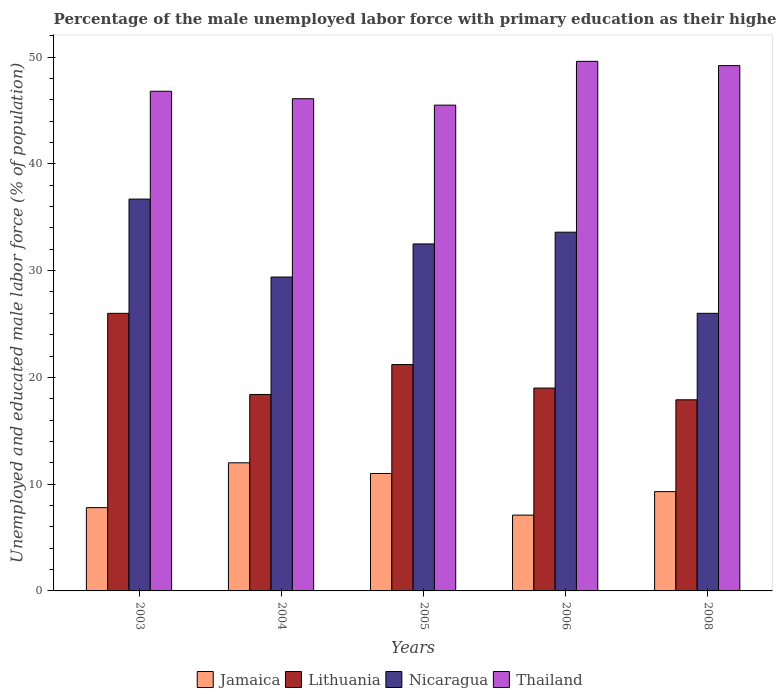How many groups of bars are there?
Provide a short and direct response. 5. How many bars are there on the 5th tick from the left?
Ensure brevity in your answer.  4. How many bars are there on the 4th tick from the right?
Provide a succinct answer. 4. What is the label of the 1st group of bars from the left?
Make the answer very short. 2003. What is the percentage of the unemployed male labor force with primary education in Jamaica in 2004?
Offer a terse response. 12. Across all years, what is the maximum percentage of the unemployed male labor force with primary education in Nicaragua?
Offer a terse response. 36.7. Across all years, what is the minimum percentage of the unemployed male labor force with primary education in Thailand?
Keep it short and to the point. 45.5. In which year was the percentage of the unemployed male labor force with primary education in Lithuania maximum?
Your answer should be compact. 2003. In which year was the percentage of the unemployed male labor force with primary education in Lithuania minimum?
Make the answer very short. 2008. What is the total percentage of the unemployed male labor force with primary education in Lithuania in the graph?
Give a very brief answer. 102.5. What is the difference between the percentage of the unemployed male labor force with primary education in Thailand in 2003 and that in 2004?
Ensure brevity in your answer.  0.7. What is the difference between the percentage of the unemployed male labor force with primary education in Nicaragua in 2005 and the percentage of the unemployed male labor force with primary education in Thailand in 2006?
Give a very brief answer. -17.1. What is the average percentage of the unemployed male labor force with primary education in Jamaica per year?
Give a very brief answer. 9.44. In the year 2004, what is the difference between the percentage of the unemployed male labor force with primary education in Thailand and percentage of the unemployed male labor force with primary education in Lithuania?
Ensure brevity in your answer.  27.7. What is the ratio of the percentage of the unemployed male labor force with primary education in Thailand in 2004 to that in 2006?
Offer a terse response. 0.93. Is the percentage of the unemployed male labor force with primary education in Thailand in 2004 less than that in 2006?
Make the answer very short. Yes. Is the difference between the percentage of the unemployed male labor force with primary education in Thailand in 2003 and 2006 greater than the difference between the percentage of the unemployed male labor force with primary education in Lithuania in 2003 and 2006?
Keep it short and to the point. No. What is the difference between the highest and the lowest percentage of the unemployed male labor force with primary education in Jamaica?
Keep it short and to the point. 4.9. Is it the case that in every year, the sum of the percentage of the unemployed male labor force with primary education in Lithuania and percentage of the unemployed male labor force with primary education in Jamaica is greater than the sum of percentage of the unemployed male labor force with primary education in Thailand and percentage of the unemployed male labor force with primary education in Nicaragua?
Your answer should be very brief. No. What does the 2nd bar from the left in 2004 represents?
Provide a short and direct response. Lithuania. What does the 2nd bar from the right in 2008 represents?
Give a very brief answer. Nicaragua. Is it the case that in every year, the sum of the percentage of the unemployed male labor force with primary education in Thailand and percentage of the unemployed male labor force with primary education in Lithuania is greater than the percentage of the unemployed male labor force with primary education in Nicaragua?
Make the answer very short. Yes. Are all the bars in the graph horizontal?
Give a very brief answer. No. Are the values on the major ticks of Y-axis written in scientific E-notation?
Your response must be concise. No. What is the title of the graph?
Ensure brevity in your answer.  Percentage of the male unemployed labor force with primary education as their highest grade. Does "Cayman Islands" appear as one of the legend labels in the graph?
Keep it short and to the point. No. What is the label or title of the X-axis?
Your answer should be compact. Years. What is the label or title of the Y-axis?
Offer a terse response. Unemployed and educated male labor force (% of population). What is the Unemployed and educated male labor force (% of population) in Jamaica in 2003?
Provide a succinct answer. 7.8. What is the Unemployed and educated male labor force (% of population) of Nicaragua in 2003?
Offer a very short reply. 36.7. What is the Unemployed and educated male labor force (% of population) in Thailand in 2003?
Your answer should be very brief. 46.8. What is the Unemployed and educated male labor force (% of population) in Lithuania in 2004?
Make the answer very short. 18.4. What is the Unemployed and educated male labor force (% of population) in Nicaragua in 2004?
Offer a very short reply. 29.4. What is the Unemployed and educated male labor force (% of population) in Thailand in 2004?
Your answer should be compact. 46.1. What is the Unemployed and educated male labor force (% of population) in Lithuania in 2005?
Provide a short and direct response. 21.2. What is the Unemployed and educated male labor force (% of population) in Nicaragua in 2005?
Make the answer very short. 32.5. What is the Unemployed and educated male labor force (% of population) of Thailand in 2005?
Make the answer very short. 45.5. What is the Unemployed and educated male labor force (% of population) in Jamaica in 2006?
Ensure brevity in your answer.  7.1. What is the Unemployed and educated male labor force (% of population) of Lithuania in 2006?
Give a very brief answer. 19. What is the Unemployed and educated male labor force (% of population) in Nicaragua in 2006?
Give a very brief answer. 33.6. What is the Unemployed and educated male labor force (% of population) of Thailand in 2006?
Provide a succinct answer. 49.6. What is the Unemployed and educated male labor force (% of population) in Jamaica in 2008?
Your response must be concise. 9.3. What is the Unemployed and educated male labor force (% of population) in Lithuania in 2008?
Offer a very short reply. 17.9. What is the Unemployed and educated male labor force (% of population) in Nicaragua in 2008?
Offer a terse response. 26. What is the Unemployed and educated male labor force (% of population) in Thailand in 2008?
Keep it short and to the point. 49.2. Across all years, what is the maximum Unemployed and educated male labor force (% of population) of Jamaica?
Ensure brevity in your answer.  12. Across all years, what is the maximum Unemployed and educated male labor force (% of population) of Lithuania?
Make the answer very short. 26. Across all years, what is the maximum Unemployed and educated male labor force (% of population) in Nicaragua?
Keep it short and to the point. 36.7. Across all years, what is the maximum Unemployed and educated male labor force (% of population) in Thailand?
Make the answer very short. 49.6. Across all years, what is the minimum Unemployed and educated male labor force (% of population) in Jamaica?
Offer a terse response. 7.1. Across all years, what is the minimum Unemployed and educated male labor force (% of population) of Lithuania?
Your response must be concise. 17.9. Across all years, what is the minimum Unemployed and educated male labor force (% of population) in Thailand?
Ensure brevity in your answer.  45.5. What is the total Unemployed and educated male labor force (% of population) in Jamaica in the graph?
Your answer should be compact. 47.2. What is the total Unemployed and educated male labor force (% of population) of Lithuania in the graph?
Provide a short and direct response. 102.5. What is the total Unemployed and educated male labor force (% of population) in Nicaragua in the graph?
Your answer should be very brief. 158.2. What is the total Unemployed and educated male labor force (% of population) of Thailand in the graph?
Offer a very short reply. 237.2. What is the difference between the Unemployed and educated male labor force (% of population) in Jamaica in 2003 and that in 2004?
Offer a very short reply. -4.2. What is the difference between the Unemployed and educated male labor force (% of population) in Lithuania in 2003 and that in 2004?
Ensure brevity in your answer.  7.6. What is the difference between the Unemployed and educated male labor force (% of population) of Nicaragua in 2003 and that in 2004?
Keep it short and to the point. 7.3. What is the difference between the Unemployed and educated male labor force (% of population) in Thailand in 2003 and that in 2004?
Your response must be concise. 0.7. What is the difference between the Unemployed and educated male labor force (% of population) of Lithuania in 2003 and that in 2005?
Offer a terse response. 4.8. What is the difference between the Unemployed and educated male labor force (% of population) in Jamaica in 2003 and that in 2006?
Your answer should be very brief. 0.7. What is the difference between the Unemployed and educated male labor force (% of population) in Lithuania in 2003 and that in 2006?
Provide a short and direct response. 7. What is the difference between the Unemployed and educated male labor force (% of population) in Nicaragua in 2003 and that in 2006?
Make the answer very short. 3.1. What is the difference between the Unemployed and educated male labor force (% of population) in Jamaica in 2003 and that in 2008?
Keep it short and to the point. -1.5. What is the difference between the Unemployed and educated male labor force (% of population) in Thailand in 2003 and that in 2008?
Give a very brief answer. -2.4. What is the difference between the Unemployed and educated male labor force (% of population) of Lithuania in 2004 and that in 2005?
Your answer should be very brief. -2.8. What is the difference between the Unemployed and educated male labor force (% of population) of Nicaragua in 2004 and that in 2005?
Offer a terse response. -3.1. What is the difference between the Unemployed and educated male labor force (% of population) of Thailand in 2004 and that in 2005?
Provide a short and direct response. 0.6. What is the difference between the Unemployed and educated male labor force (% of population) of Jamaica in 2004 and that in 2006?
Your response must be concise. 4.9. What is the difference between the Unemployed and educated male labor force (% of population) in Lithuania in 2004 and that in 2006?
Offer a terse response. -0.6. What is the difference between the Unemployed and educated male labor force (% of population) of Thailand in 2004 and that in 2006?
Your answer should be very brief. -3.5. What is the difference between the Unemployed and educated male labor force (% of population) of Jamaica in 2004 and that in 2008?
Ensure brevity in your answer.  2.7. What is the difference between the Unemployed and educated male labor force (% of population) in Lithuania in 2004 and that in 2008?
Give a very brief answer. 0.5. What is the difference between the Unemployed and educated male labor force (% of population) in Nicaragua in 2004 and that in 2008?
Offer a terse response. 3.4. What is the difference between the Unemployed and educated male labor force (% of population) in Thailand in 2004 and that in 2008?
Offer a terse response. -3.1. What is the difference between the Unemployed and educated male labor force (% of population) in Jamaica in 2005 and that in 2006?
Keep it short and to the point. 3.9. What is the difference between the Unemployed and educated male labor force (% of population) in Nicaragua in 2005 and that in 2006?
Ensure brevity in your answer.  -1.1. What is the difference between the Unemployed and educated male labor force (% of population) in Jamaica in 2005 and that in 2008?
Provide a succinct answer. 1.7. What is the difference between the Unemployed and educated male labor force (% of population) in Thailand in 2005 and that in 2008?
Offer a very short reply. -3.7. What is the difference between the Unemployed and educated male labor force (% of population) in Jamaica in 2006 and that in 2008?
Provide a succinct answer. -2.2. What is the difference between the Unemployed and educated male labor force (% of population) of Jamaica in 2003 and the Unemployed and educated male labor force (% of population) of Lithuania in 2004?
Ensure brevity in your answer.  -10.6. What is the difference between the Unemployed and educated male labor force (% of population) in Jamaica in 2003 and the Unemployed and educated male labor force (% of population) in Nicaragua in 2004?
Provide a short and direct response. -21.6. What is the difference between the Unemployed and educated male labor force (% of population) in Jamaica in 2003 and the Unemployed and educated male labor force (% of population) in Thailand in 2004?
Give a very brief answer. -38.3. What is the difference between the Unemployed and educated male labor force (% of population) of Lithuania in 2003 and the Unemployed and educated male labor force (% of population) of Nicaragua in 2004?
Your answer should be very brief. -3.4. What is the difference between the Unemployed and educated male labor force (% of population) of Lithuania in 2003 and the Unemployed and educated male labor force (% of population) of Thailand in 2004?
Your response must be concise. -20.1. What is the difference between the Unemployed and educated male labor force (% of population) in Jamaica in 2003 and the Unemployed and educated male labor force (% of population) in Nicaragua in 2005?
Make the answer very short. -24.7. What is the difference between the Unemployed and educated male labor force (% of population) of Jamaica in 2003 and the Unemployed and educated male labor force (% of population) of Thailand in 2005?
Give a very brief answer. -37.7. What is the difference between the Unemployed and educated male labor force (% of population) of Lithuania in 2003 and the Unemployed and educated male labor force (% of population) of Thailand in 2005?
Your answer should be compact. -19.5. What is the difference between the Unemployed and educated male labor force (% of population) in Nicaragua in 2003 and the Unemployed and educated male labor force (% of population) in Thailand in 2005?
Provide a succinct answer. -8.8. What is the difference between the Unemployed and educated male labor force (% of population) in Jamaica in 2003 and the Unemployed and educated male labor force (% of population) in Nicaragua in 2006?
Offer a terse response. -25.8. What is the difference between the Unemployed and educated male labor force (% of population) in Jamaica in 2003 and the Unemployed and educated male labor force (% of population) in Thailand in 2006?
Your answer should be compact. -41.8. What is the difference between the Unemployed and educated male labor force (% of population) in Lithuania in 2003 and the Unemployed and educated male labor force (% of population) in Thailand in 2006?
Keep it short and to the point. -23.6. What is the difference between the Unemployed and educated male labor force (% of population) in Jamaica in 2003 and the Unemployed and educated male labor force (% of population) in Nicaragua in 2008?
Your answer should be compact. -18.2. What is the difference between the Unemployed and educated male labor force (% of population) of Jamaica in 2003 and the Unemployed and educated male labor force (% of population) of Thailand in 2008?
Offer a very short reply. -41.4. What is the difference between the Unemployed and educated male labor force (% of population) of Lithuania in 2003 and the Unemployed and educated male labor force (% of population) of Thailand in 2008?
Offer a terse response. -23.2. What is the difference between the Unemployed and educated male labor force (% of population) in Nicaragua in 2003 and the Unemployed and educated male labor force (% of population) in Thailand in 2008?
Keep it short and to the point. -12.5. What is the difference between the Unemployed and educated male labor force (% of population) of Jamaica in 2004 and the Unemployed and educated male labor force (% of population) of Nicaragua in 2005?
Give a very brief answer. -20.5. What is the difference between the Unemployed and educated male labor force (% of population) in Jamaica in 2004 and the Unemployed and educated male labor force (% of population) in Thailand in 2005?
Your answer should be compact. -33.5. What is the difference between the Unemployed and educated male labor force (% of population) in Lithuania in 2004 and the Unemployed and educated male labor force (% of population) in Nicaragua in 2005?
Your answer should be very brief. -14.1. What is the difference between the Unemployed and educated male labor force (% of population) of Lithuania in 2004 and the Unemployed and educated male labor force (% of population) of Thailand in 2005?
Your answer should be very brief. -27.1. What is the difference between the Unemployed and educated male labor force (% of population) of Nicaragua in 2004 and the Unemployed and educated male labor force (% of population) of Thailand in 2005?
Your response must be concise. -16.1. What is the difference between the Unemployed and educated male labor force (% of population) of Jamaica in 2004 and the Unemployed and educated male labor force (% of population) of Nicaragua in 2006?
Provide a succinct answer. -21.6. What is the difference between the Unemployed and educated male labor force (% of population) in Jamaica in 2004 and the Unemployed and educated male labor force (% of population) in Thailand in 2006?
Provide a succinct answer. -37.6. What is the difference between the Unemployed and educated male labor force (% of population) of Lithuania in 2004 and the Unemployed and educated male labor force (% of population) of Nicaragua in 2006?
Keep it short and to the point. -15.2. What is the difference between the Unemployed and educated male labor force (% of population) in Lithuania in 2004 and the Unemployed and educated male labor force (% of population) in Thailand in 2006?
Ensure brevity in your answer.  -31.2. What is the difference between the Unemployed and educated male labor force (% of population) in Nicaragua in 2004 and the Unemployed and educated male labor force (% of population) in Thailand in 2006?
Make the answer very short. -20.2. What is the difference between the Unemployed and educated male labor force (% of population) of Jamaica in 2004 and the Unemployed and educated male labor force (% of population) of Nicaragua in 2008?
Ensure brevity in your answer.  -14. What is the difference between the Unemployed and educated male labor force (% of population) in Jamaica in 2004 and the Unemployed and educated male labor force (% of population) in Thailand in 2008?
Provide a succinct answer. -37.2. What is the difference between the Unemployed and educated male labor force (% of population) in Lithuania in 2004 and the Unemployed and educated male labor force (% of population) in Thailand in 2008?
Your answer should be compact. -30.8. What is the difference between the Unemployed and educated male labor force (% of population) in Nicaragua in 2004 and the Unemployed and educated male labor force (% of population) in Thailand in 2008?
Offer a very short reply. -19.8. What is the difference between the Unemployed and educated male labor force (% of population) of Jamaica in 2005 and the Unemployed and educated male labor force (% of population) of Lithuania in 2006?
Offer a very short reply. -8. What is the difference between the Unemployed and educated male labor force (% of population) of Jamaica in 2005 and the Unemployed and educated male labor force (% of population) of Nicaragua in 2006?
Your answer should be compact. -22.6. What is the difference between the Unemployed and educated male labor force (% of population) in Jamaica in 2005 and the Unemployed and educated male labor force (% of population) in Thailand in 2006?
Give a very brief answer. -38.6. What is the difference between the Unemployed and educated male labor force (% of population) in Lithuania in 2005 and the Unemployed and educated male labor force (% of population) in Nicaragua in 2006?
Offer a very short reply. -12.4. What is the difference between the Unemployed and educated male labor force (% of population) of Lithuania in 2005 and the Unemployed and educated male labor force (% of population) of Thailand in 2006?
Ensure brevity in your answer.  -28.4. What is the difference between the Unemployed and educated male labor force (% of population) of Nicaragua in 2005 and the Unemployed and educated male labor force (% of population) of Thailand in 2006?
Ensure brevity in your answer.  -17.1. What is the difference between the Unemployed and educated male labor force (% of population) of Jamaica in 2005 and the Unemployed and educated male labor force (% of population) of Lithuania in 2008?
Make the answer very short. -6.9. What is the difference between the Unemployed and educated male labor force (% of population) of Jamaica in 2005 and the Unemployed and educated male labor force (% of population) of Nicaragua in 2008?
Keep it short and to the point. -15. What is the difference between the Unemployed and educated male labor force (% of population) of Jamaica in 2005 and the Unemployed and educated male labor force (% of population) of Thailand in 2008?
Make the answer very short. -38.2. What is the difference between the Unemployed and educated male labor force (% of population) in Lithuania in 2005 and the Unemployed and educated male labor force (% of population) in Nicaragua in 2008?
Offer a very short reply. -4.8. What is the difference between the Unemployed and educated male labor force (% of population) of Lithuania in 2005 and the Unemployed and educated male labor force (% of population) of Thailand in 2008?
Offer a very short reply. -28. What is the difference between the Unemployed and educated male labor force (% of population) in Nicaragua in 2005 and the Unemployed and educated male labor force (% of population) in Thailand in 2008?
Offer a very short reply. -16.7. What is the difference between the Unemployed and educated male labor force (% of population) in Jamaica in 2006 and the Unemployed and educated male labor force (% of population) in Nicaragua in 2008?
Provide a short and direct response. -18.9. What is the difference between the Unemployed and educated male labor force (% of population) of Jamaica in 2006 and the Unemployed and educated male labor force (% of population) of Thailand in 2008?
Offer a very short reply. -42.1. What is the difference between the Unemployed and educated male labor force (% of population) of Lithuania in 2006 and the Unemployed and educated male labor force (% of population) of Thailand in 2008?
Provide a succinct answer. -30.2. What is the difference between the Unemployed and educated male labor force (% of population) in Nicaragua in 2006 and the Unemployed and educated male labor force (% of population) in Thailand in 2008?
Your answer should be compact. -15.6. What is the average Unemployed and educated male labor force (% of population) in Jamaica per year?
Your answer should be very brief. 9.44. What is the average Unemployed and educated male labor force (% of population) of Lithuania per year?
Provide a short and direct response. 20.5. What is the average Unemployed and educated male labor force (% of population) of Nicaragua per year?
Your answer should be very brief. 31.64. What is the average Unemployed and educated male labor force (% of population) of Thailand per year?
Provide a succinct answer. 47.44. In the year 2003, what is the difference between the Unemployed and educated male labor force (% of population) in Jamaica and Unemployed and educated male labor force (% of population) in Lithuania?
Provide a short and direct response. -18.2. In the year 2003, what is the difference between the Unemployed and educated male labor force (% of population) of Jamaica and Unemployed and educated male labor force (% of population) of Nicaragua?
Ensure brevity in your answer.  -28.9. In the year 2003, what is the difference between the Unemployed and educated male labor force (% of population) of Jamaica and Unemployed and educated male labor force (% of population) of Thailand?
Offer a very short reply. -39. In the year 2003, what is the difference between the Unemployed and educated male labor force (% of population) of Lithuania and Unemployed and educated male labor force (% of population) of Thailand?
Provide a short and direct response. -20.8. In the year 2004, what is the difference between the Unemployed and educated male labor force (% of population) of Jamaica and Unemployed and educated male labor force (% of population) of Lithuania?
Offer a very short reply. -6.4. In the year 2004, what is the difference between the Unemployed and educated male labor force (% of population) in Jamaica and Unemployed and educated male labor force (% of population) in Nicaragua?
Your answer should be very brief. -17.4. In the year 2004, what is the difference between the Unemployed and educated male labor force (% of population) of Jamaica and Unemployed and educated male labor force (% of population) of Thailand?
Offer a terse response. -34.1. In the year 2004, what is the difference between the Unemployed and educated male labor force (% of population) of Lithuania and Unemployed and educated male labor force (% of population) of Thailand?
Your response must be concise. -27.7. In the year 2004, what is the difference between the Unemployed and educated male labor force (% of population) of Nicaragua and Unemployed and educated male labor force (% of population) of Thailand?
Your answer should be very brief. -16.7. In the year 2005, what is the difference between the Unemployed and educated male labor force (% of population) of Jamaica and Unemployed and educated male labor force (% of population) of Nicaragua?
Offer a terse response. -21.5. In the year 2005, what is the difference between the Unemployed and educated male labor force (% of population) in Jamaica and Unemployed and educated male labor force (% of population) in Thailand?
Your answer should be compact. -34.5. In the year 2005, what is the difference between the Unemployed and educated male labor force (% of population) of Lithuania and Unemployed and educated male labor force (% of population) of Thailand?
Offer a terse response. -24.3. In the year 2005, what is the difference between the Unemployed and educated male labor force (% of population) of Nicaragua and Unemployed and educated male labor force (% of population) of Thailand?
Offer a very short reply. -13. In the year 2006, what is the difference between the Unemployed and educated male labor force (% of population) of Jamaica and Unemployed and educated male labor force (% of population) of Lithuania?
Give a very brief answer. -11.9. In the year 2006, what is the difference between the Unemployed and educated male labor force (% of population) of Jamaica and Unemployed and educated male labor force (% of population) of Nicaragua?
Give a very brief answer. -26.5. In the year 2006, what is the difference between the Unemployed and educated male labor force (% of population) of Jamaica and Unemployed and educated male labor force (% of population) of Thailand?
Ensure brevity in your answer.  -42.5. In the year 2006, what is the difference between the Unemployed and educated male labor force (% of population) in Lithuania and Unemployed and educated male labor force (% of population) in Nicaragua?
Give a very brief answer. -14.6. In the year 2006, what is the difference between the Unemployed and educated male labor force (% of population) in Lithuania and Unemployed and educated male labor force (% of population) in Thailand?
Provide a short and direct response. -30.6. In the year 2006, what is the difference between the Unemployed and educated male labor force (% of population) in Nicaragua and Unemployed and educated male labor force (% of population) in Thailand?
Offer a terse response. -16. In the year 2008, what is the difference between the Unemployed and educated male labor force (% of population) of Jamaica and Unemployed and educated male labor force (% of population) of Lithuania?
Your response must be concise. -8.6. In the year 2008, what is the difference between the Unemployed and educated male labor force (% of population) of Jamaica and Unemployed and educated male labor force (% of population) of Nicaragua?
Provide a short and direct response. -16.7. In the year 2008, what is the difference between the Unemployed and educated male labor force (% of population) in Jamaica and Unemployed and educated male labor force (% of population) in Thailand?
Make the answer very short. -39.9. In the year 2008, what is the difference between the Unemployed and educated male labor force (% of population) in Lithuania and Unemployed and educated male labor force (% of population) in Thailand?
Your answer should be compact. -31.3. In the year 2008, what is the difference between the Unemployed and educated male labor force (% of population) in Nicaragua and Unemployed and educated male labor force (% of population) in Thailand?
Make the answer very short. -23.2. What is the ratio of the Unemployed and educated male labor force (% of population) of Jamaica in 2003 to that in 2004?
Provide a short and direct response. 0.65. What is the ratio of the Unemployed and educated male labor force (% of population) in Lithuania in 2003 to that in 2004?
Your answer should be compact. 1.41. What is the ratio of the Unemployed and educated male labor force (% of population) in Nicaragua in 2003 to that in 2004?
Your response must be concise. 1.25. What is the ratio of the Unemployed and educated male labor force (% of population) of Thailand in 2003 to that in 2004?
Provide a short and direct response. 1.02. What is the ratio of the Unemployed and educated male labor force (% of population) in Jamaica in 2003 to that in 2005?
Keep it short and to the point. 0.71. What is the ratio of the Unemployed and educated male labor force (% of population) of Lithuania in 2003 to that in 2005?
Your response must be concise. 1.23. What is the ratio of the Unemployed and educated male labor force (% of population) in Nicaragua in 2003 to that in 2005?
Give a very brief answer. 1.13. What is the ratio of the Unemployed and educated male labor force (% of population) of Thailand in 2003 to that in 2005?
Give a very brief answer. 1.03. What is the ratio of the Unemployed and educated male labor force (% of population) of Jamaica in 2003 to that in 2006?
Provide a short and direct response. 1.1. What is the ratio of the Unemployed and educated male labor force (% of population) in Lithuania in 2003 to that in 2006?
Provide a succinct answer. 1.37. What is the ratio of the Unemployed and educated male labor force (% of population) of Nicaragua in 2003 to that in 2006?
Provide a succinct answer. 1.09. What is the ratio of the Unemployed and educated male labor force (% of population) in Thailand in 2003 to that in 2006?
Offer a terse response. 0.94. What is the ratio of the Unemployed and educated male labor force (% of population) of Jamaica in 2003 to that in 2008?
Ensure brevity in your answer.  0.84. What is the ratio of the Unemployed and educated male labor force (% of population) in Lithuania in 2003 to that in 2008?
Your answer should be very brief. 1.45. What is the ratio of the Unemployed and educated male labor force (% of population) of Nicaragua in 2003 to that in 2008?
Your answer should be very brief. 1.41. What is the ratio of the Unemployed and educated male labor force (% of population) of Thailand in 2003 to that in 2008?
Your answer should be compact. 0.95. What is the ratio of the Unemployed and educated male labor force (% of population) in Lithuania in 2004 to that in 2005?
Provide a short and direct response. 0.87. What is the ratio of the Unemployed and educated male labor force (% of population) of Nicaragua in 2004 to that in 2005?
Your response must be concise. 0.9. What is the ratio of the Unemployed and educated male labor force (% of population) of Thailand in 2004 to that in 2005?
Your response must be concise. 1.01. What is the ratio of the Unemployed and educated male labor force (% of population) of Jamaica in 2004 to that in 2006?
Keep it short and to the point. 1.69. What is the ratio of the Unemployed and educated male labor force (% of population) of Lithuania in 2004 to that in 2006?
Give a very brief answer. 0.97. What is the ratio of the Unemployed and educated male labor force (% of population) of Nicaragua in 2004 to that in 2006?
Your answer should be very brief. 0.88. What is the ratio of the Unemployed and educated male labor force (% of population) in Thailand in 2004 to that in 2006?
Your answer should be compact. 0.93. What is the ratio of the Unemployed and educated male labor force (% of population) in Jamaica in 2004 to that in 2008?
Offer a terse response. 1.29. What is the ratio of the Unemployed and educated male labor force (% of population) of Lithuania in 2004 to that in 2008?
Keep it short and to the point. 1.03. What is the ratio of the Unemployed and educated male labor force (% of population) in Nicaragua in 2004 to that in 2008?
Make the answer very short. 1.13. What is the ratio of the Unemployed and educated male labor force (% of population) of Thailand in 2004 to that in 2008?
Keep it short and to the point. 0.94. What is the ratio of the Unemployed and educated male labor force (% of population) of Jamaica in 2005 to that in 2006?
Give a very brief answer. 1.55. What is the ratio of the Unemployed and educated male labor force (% of population) of Lithuania in 2005 to that in 2006?
Make the answer very short. 1.12. What is the ratio of the Unemployed and educated male labor force (% of population) in Nicaragua in 2005 to that in 2006?
Your response must be concise. 0.97. What is the ratio of the Unemployed and educated male labor force (% of population) of Thailand in 2005 to that in 2006?
Provide a succinct answer. 0.92. What is the ratio of the Unemployed and educated male labor force (% of population) of Jamaica in 2005 to that in 2008?
Keep it short and to the point. 1.18. What is the ratio of the Unemployed and educated male labor force (% of population) in Lithuania in 2005 to that in 2008?
Ensure brevity in your answer.  1.18. What is the ratio of the Unemployed and educated male labor force (% of population) in Nicaragua in 2005 to that in 2008?
Keep it short and to the point. 1.25. What is the ratio of the Unemployed and educated male labor force (% of population) of Thailand in 2005 to that in 2008?
Offer a terse response. 0.92. What is the ratio of the Unemployed and educated male labor force (% of population) of Jamaica in 2006 to that in 2008?
Provide a short and direct response. 0.76. What is the ratio of the Unemployed and educated male labor force (% of population) of Lithuania in 2006 to that in 2008?
Ensure brevity in your answer.  1.06. What is the ratio of the Unemployed and educated male labor force (% of population) of Nicaragua in 2006 to that in 2008?
Give a very brief answer. 1.29. What is the ratio of the Unemployed and educated male labor force (% of population) in Thailand in 2006 to that in 2008?
Ensure brevity in your answer.  1.01. What is the difference between the highest and the second highest Unemployed and educated male labor force (% of population) of Nicaragua?
Offer a very short reply. 3.1. What is the difference between the highest and the lowest Unemployed and educated male labor force (% of population) of Jamaica?
Provide a succinct answer. 4.9. 